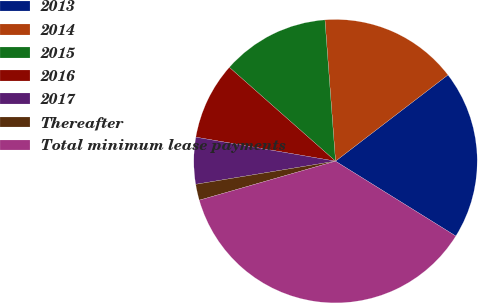Convert chart. <chart><loc_0><loc_0><loc_500><loc_500><pie_chart><fcel>2013<fcel>2014<fcel>2015<fcel>2016<fcel>2017<fcel>Thereafter<fcel>Total minimum lease payments<nl><fcel>19.27%<fcel>15.78%<fcel>12.29%<fcel>8.81%<fcel>5.32%<fcel>1.83%<fcel>36.7%<nl></chart> 